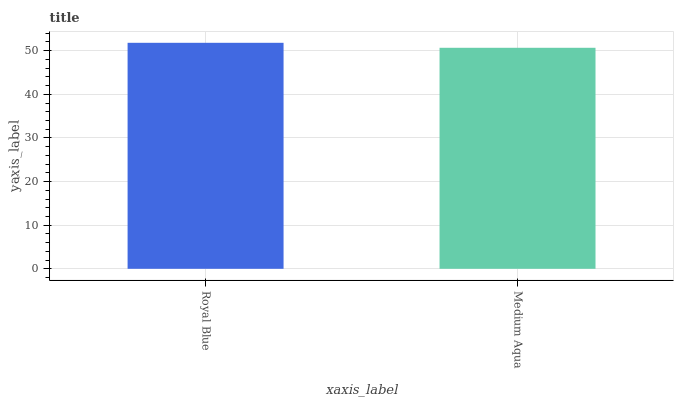Is Medium Aqua the minimum?
Answer yes or no. Yes. Is Royal Blue the maximum?
Answer yes or no. Yes. Is Medium Aqua the maximum?
Answer yes or no. No. Is Royal Blue greater than Medium Aqua?
Answer yes or no. Yes. Is Medium Aqua less than Royal Blue?
Answer yes or no. Yes. Is Medium Aqua greater than Royal Blue?
Answer yes or no. No. Is Royal Blue less than Medium Aqua?
Answer yes or no. No. Is Royal Blue the high median?
Answer yes or no. Yes. Is Medium Aqua the low median?
Answer yes or no. Yes. Is Medium Aqua the high median?
Answer yes or no. No. Is Royal Blue the low median?
Answer yes or no. No. 